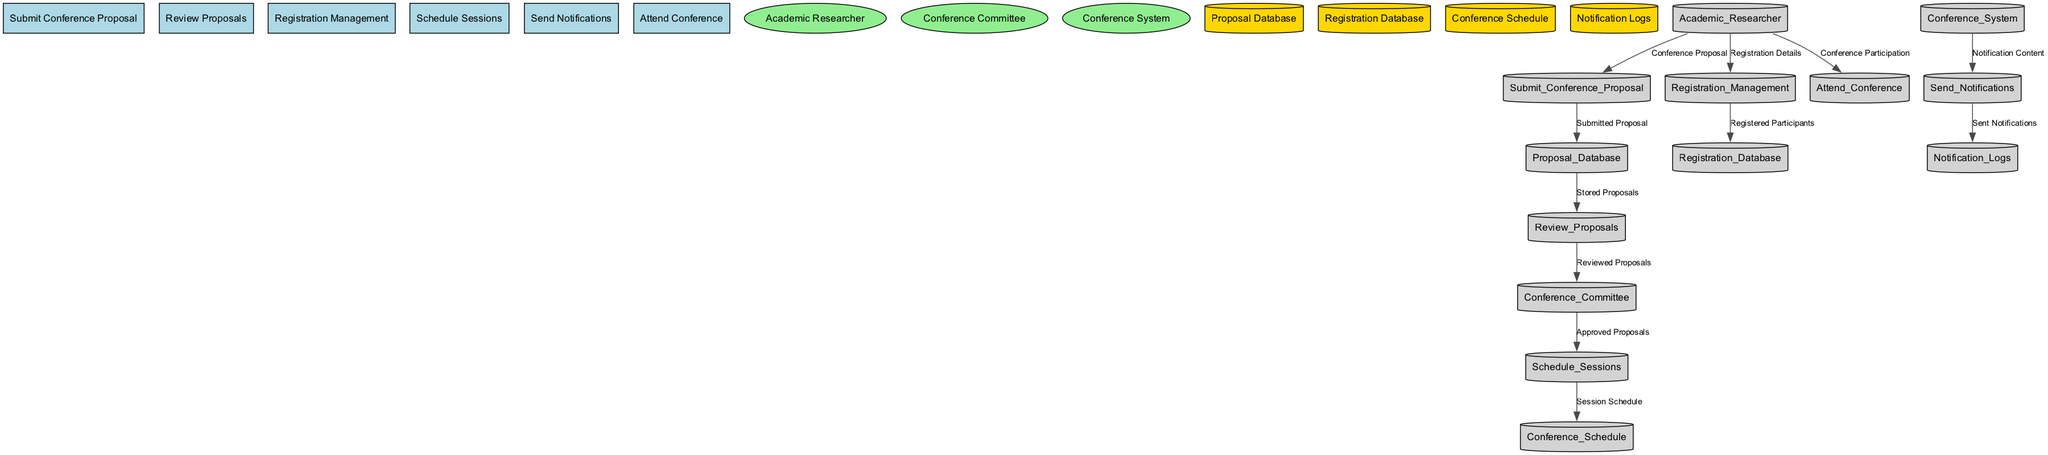What is the first process in the diagram? The first process is labeled as "Submit Conference Proposal," which is the starting point of the workflow outlined in the diagram.
Answer: Submit Conference Proposal How many external entities are represented? There are three external entities identified in the diagram: Academic Researcher, Conference Committee, and Conference System.
Answer: 3 Which process receives data from the Proposal Database? The process that receives data from the Proposal Database is "Review Proposals," which is the next step after storing the submitted proposals.
Answer: Review Proposals What data flows from Registration Management to Registration Database? The data that flows from Registration Management to Registration Database is "Registered Participants," indicating that the registration details of individuals are stored here.
Answer: Registered Participants Which external entity sends notifications? The external entity that sends notifications is the Conference System, which generates the notification content for various conference-related communications.
Answer: Conference System How many processes send data to the Conference Committee? There is one process that sends data to the Conference Committee, which is "Review Proposals," transferring the reviewed proposals for approval.
Answer: 1 What is the final action performed by an Academic Researcher? The final action performed by an Academic Researcher is "Attend Conference," marking the conclusion of the workflow related to the conference management process.
Answer: Attend Conference From which process is the Session Schedule generated? The "Schedule Sessions" process is responsible for producing the "Session Schedule," which organizes the allocated time slots for the conference sessions.
Answer: Schedule Sessions What data do the Notification Logs capture? The Notification Logs capture "Sent Notifications," which document all notifications that have been dispatched during the conference management process.
Answer: Sent Notifications 